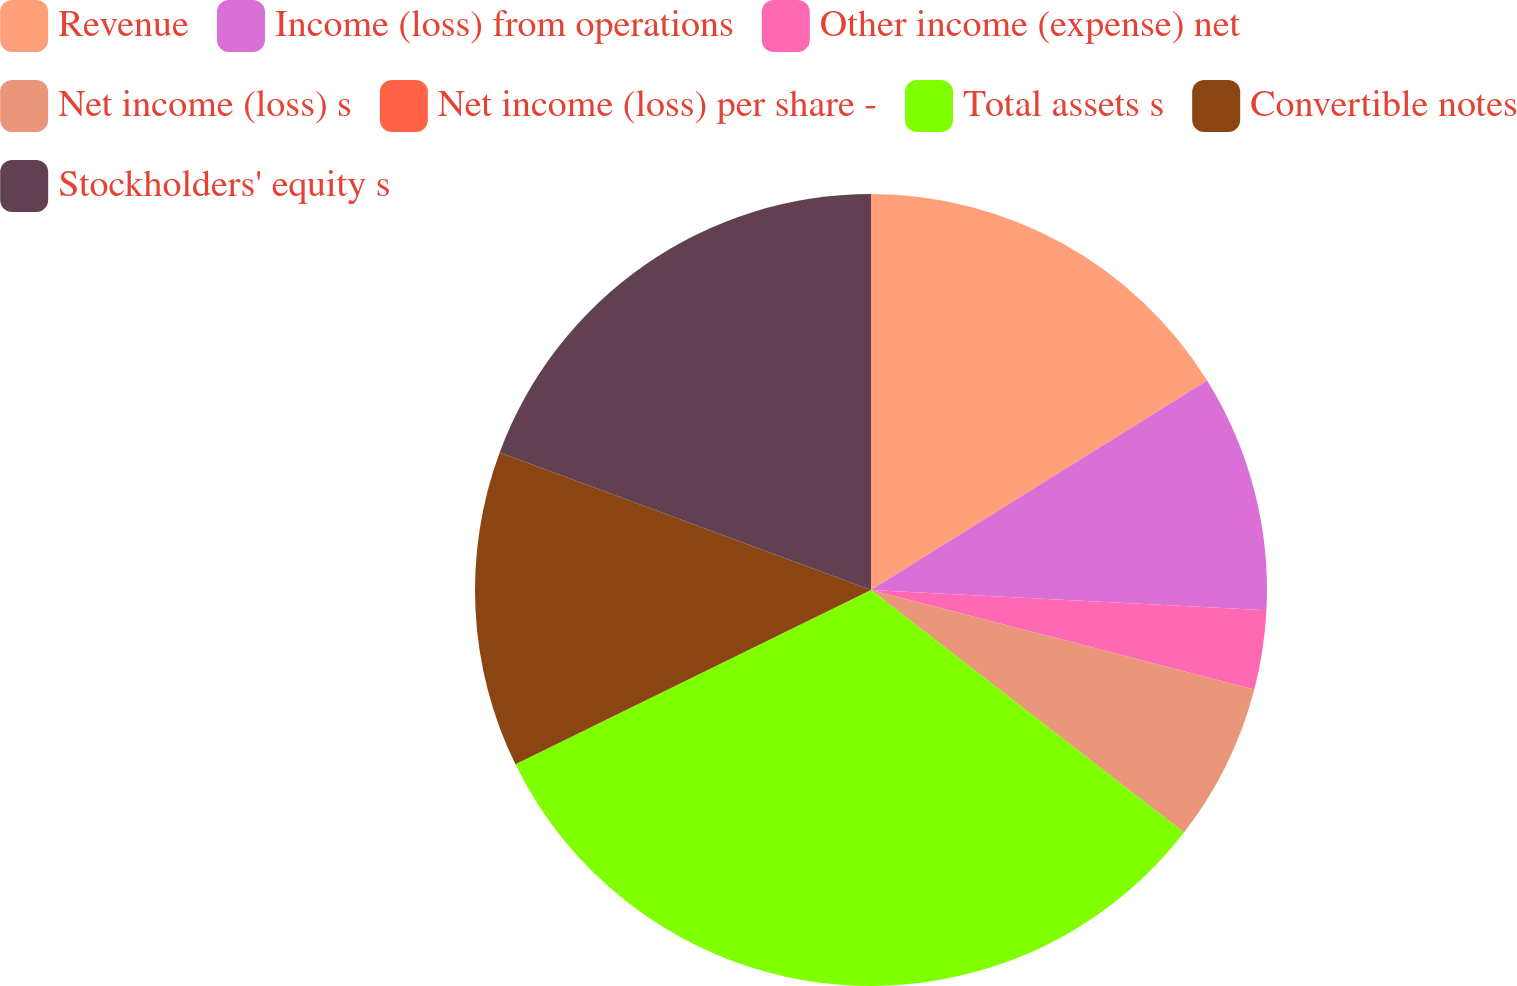Convert chart to OTSL. <chart><loc_0><loc_0><loc_500><loc_500><pie_chart><fcel>Revenue<fcel>Income (loss) from operations<fcel>Other income (expense) net<fcel>Net income (loss) s<fcel>Net income (loss) per share -<fcel>Total assets s<fcel>Convertible notes<fcel>Stockholders' equity s<nl><fcel>16.13%<fcel>9.68%<fcel>3.23%<fcel>6.45%<fcel>0.0%<fcel>32.25%<fcel>12.9%<fcel>19.35%<nl></chart> 